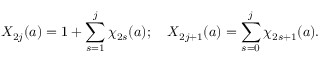Convert formula to latex. <formula><loc_0><loc_0><loc_500><loc_500>X _ { 2 j } ( a ) = 1 + \sum _ { s = 1 } ^ { j } \chi _ { 2 s } ( a ) ; \quad X _ { 2 j + 1 } ( a ) = \sum _ { s = 0 } ^ { j } \chi _ { 2 s + 1 } ( a ) .</formula> 